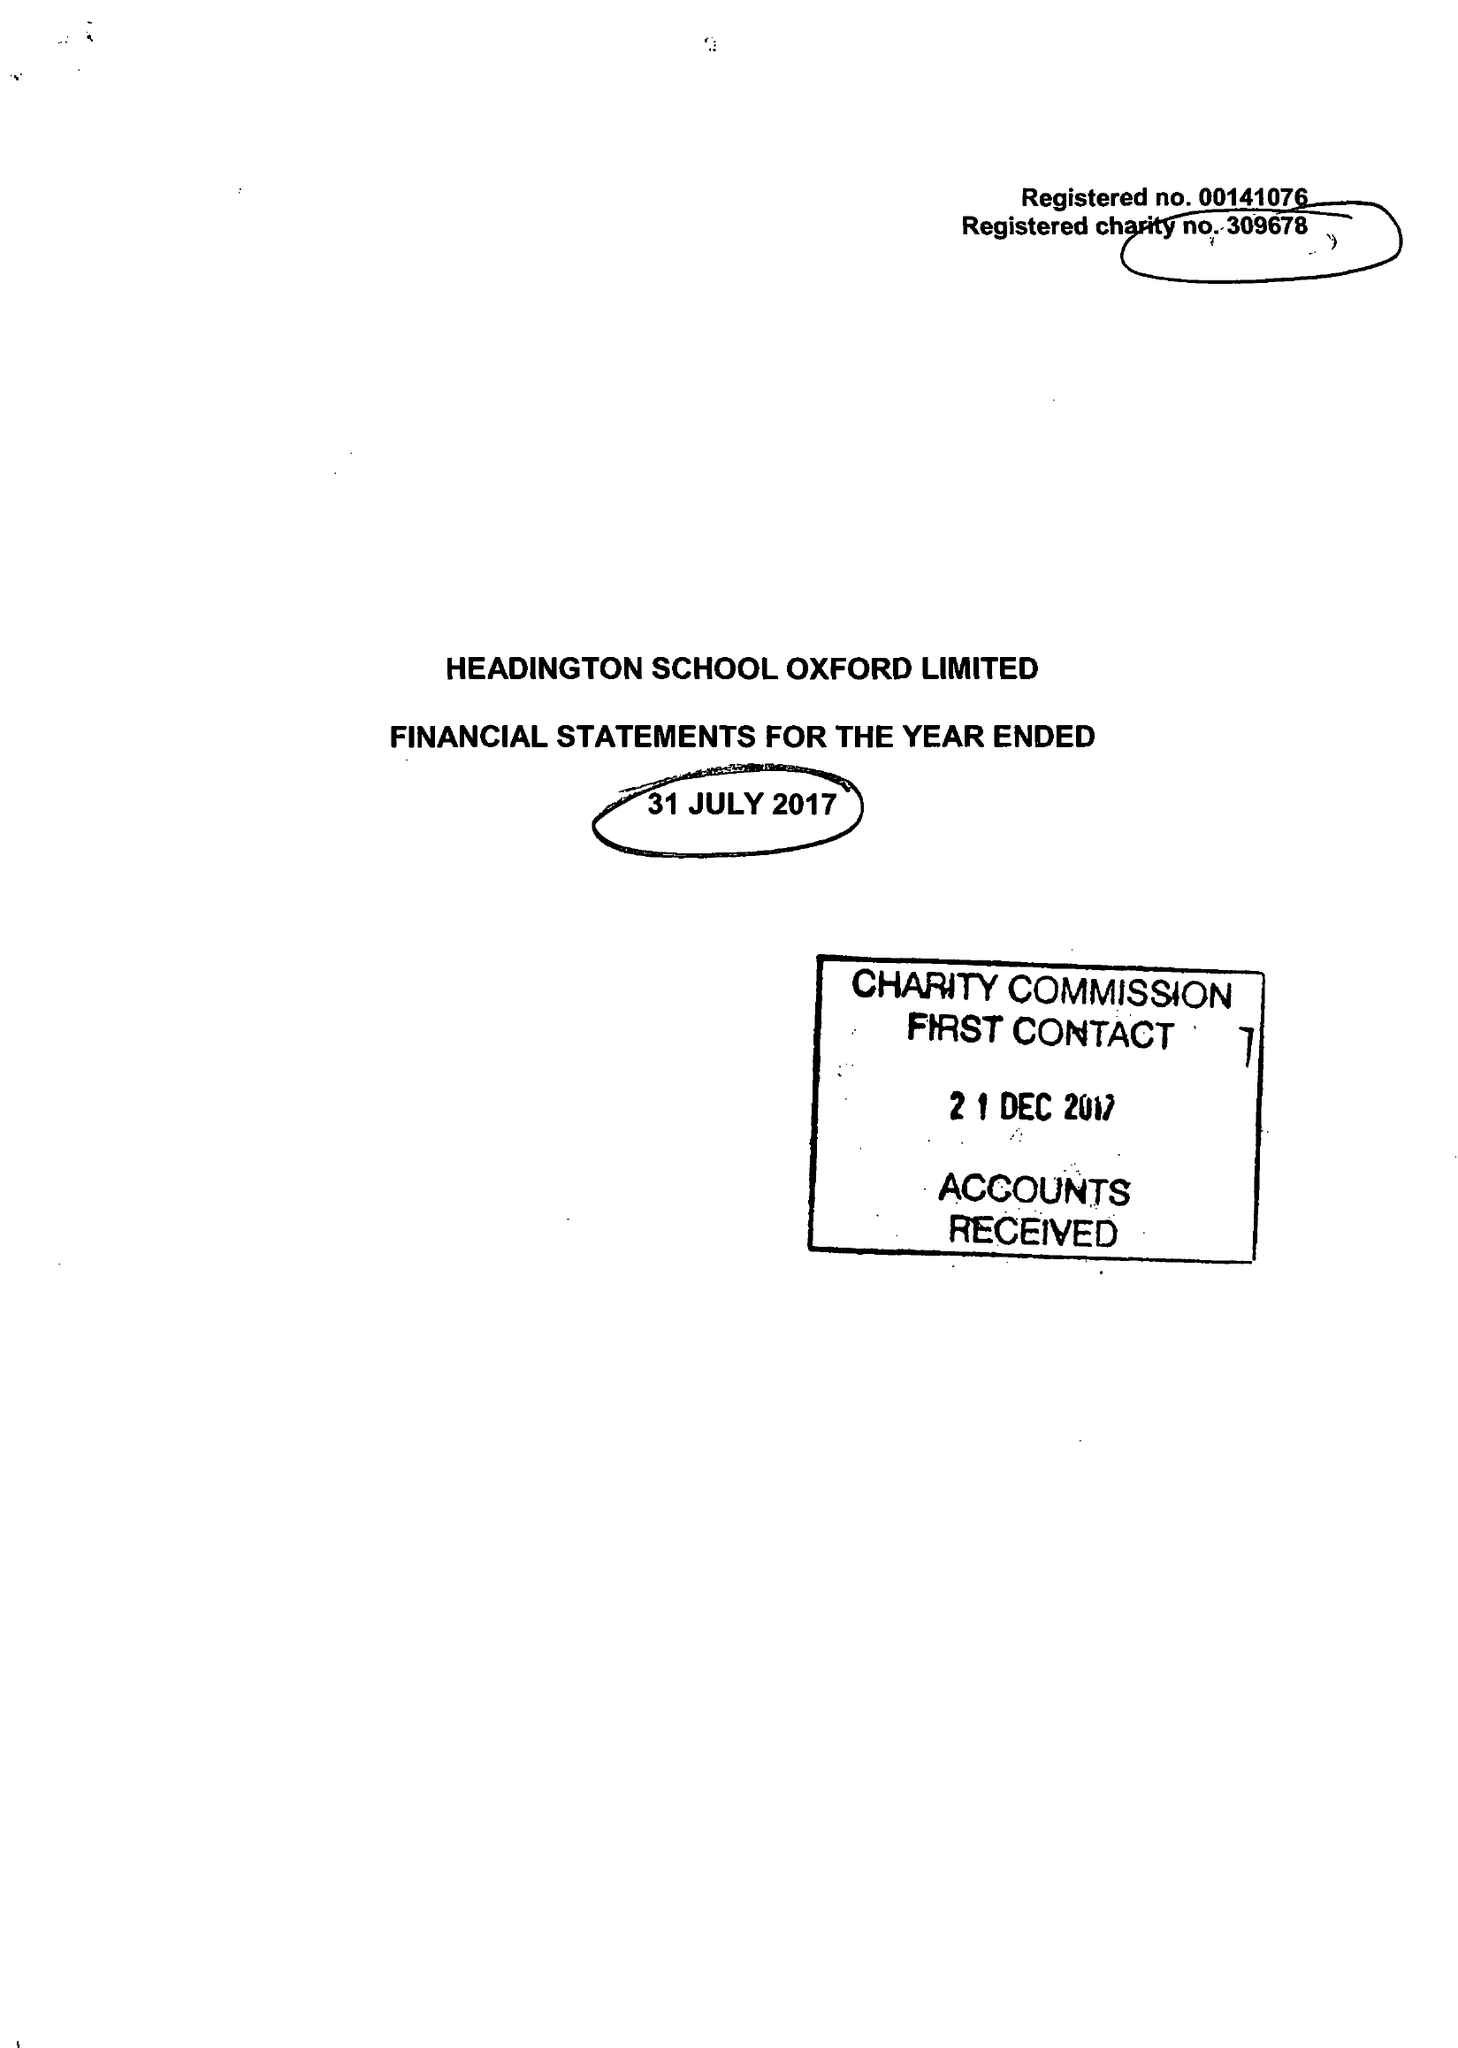What is the value for the address__postcode?
Answer the question using a single word or phrase. OX3 0BL 